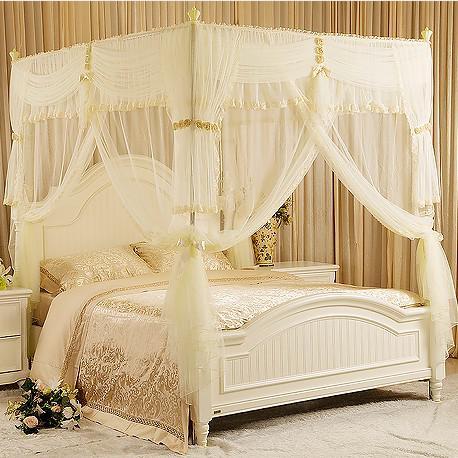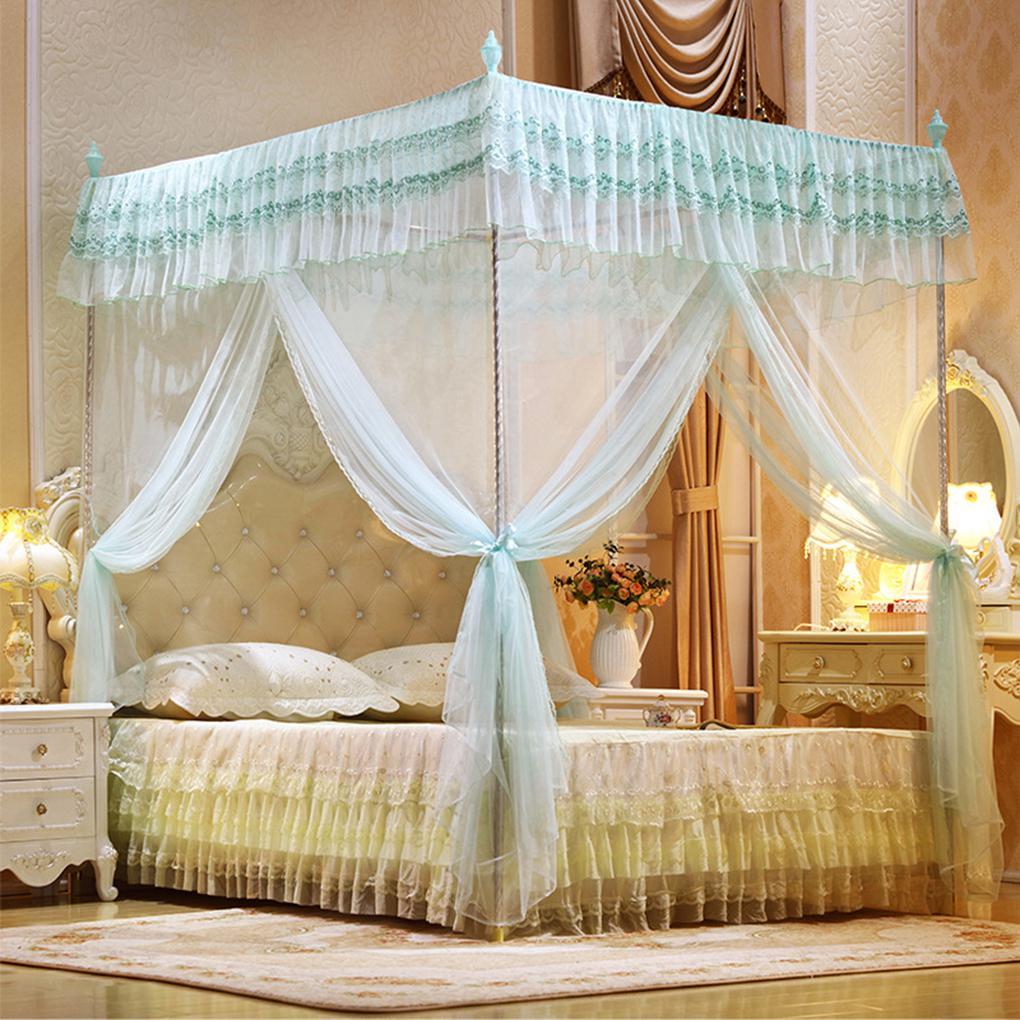The first image is the image on the left, the second image is the image on the right. For the images shown, is this caption "The canopy bed on the right has a two-drawer chest next to it." true? Answer yes or no. Yes. The first image is the image on the left, the second image is the image on the right. For the images shown, is this caption "Both images show four-posted beds with curtain type canopies." true? Answer yes or no. Yes. 